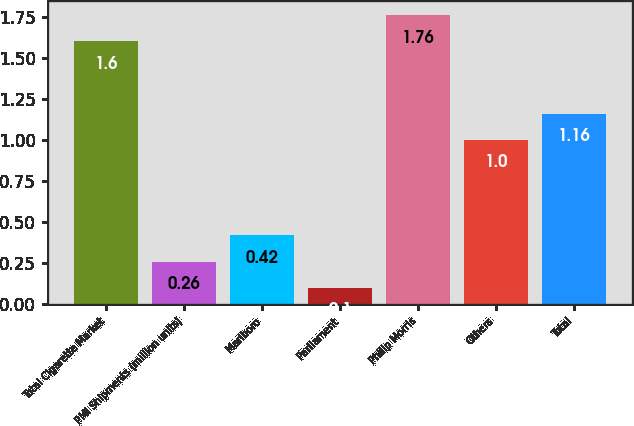<chart> <loc_0><loc_0><loc_500><loc_500><bar_chart><fcel>Total Cigarette Market<fcel>PMI Shipments (million units)<fcel>Marlboro<fcel>Parliament<fcel>Philip Morris<fcel>Others<fcel>Total<nl><fcel>1.6<fcel>0.26<fcel>0.42<fcel>0.1<fcel>1.76<fcel>1<fcel>1.16<nl></chart> 